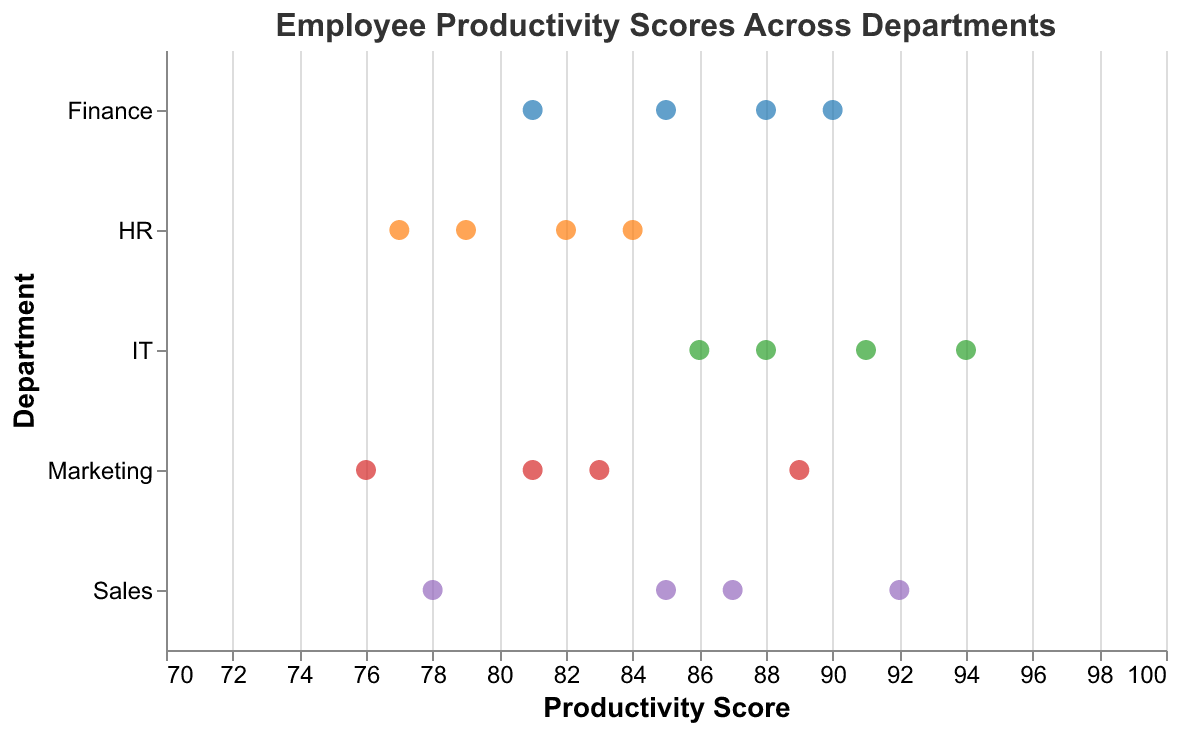What's the title of the plot? The title of the plot is typically placed at the top of the figure and is clearly visible. In this case, the title is "Employee Productivity Scores Across Departments".
Answer: Employee Productivity Scores Across Departments How many employees are in the HR department? The plot shows individual data points for each employee, and by counting these points within the HR department area, we find that there are four employees.
Answer: 4 Which department has the highest individual productivity score? By looking for the highest positioned data point on the x-axis, which represents the productivity score, the highest score is 94 in the IT department.
Answer: IT What's the average productivity score for the Sales department? The productivity scores for Sales are 87, 92, 78, and 85. Summing these up gives 342, and dividing by the number of employees (which is 4) gives an average of 85.5.
Answer: 85.5 Which department has the lowest average productivity score? Calculate the average productivity score for each department: Sales (85.5), Marketing (82.3), IT (89.75), HR (80.5), Finance (86). Comparing these, Marketing has the lowest average productivity score.
Answer: Marketing How many departments have an employee with a productivity score above 90? Identify the departments that have at least one data point above the score of 90: Sales, IT, and Finance have such scores. A total of three departments meet this criterion.
Answer: 3 Is there any department where all employees have productivity scores below 80? Check each department: none of the departments (Sales, Marketing, IT, HR, and Finance) have all employees with scores below 80.
Answer: No What is the range of productivity scores in the Finance department? The productivity scores for Finance are 90, 85, 88, and 81. The range is calculated as the difference between the highest (90) and the lowest (81) scores, which is 90 - 81 = 9.
Answer: 9 Which two departments show the most overlap in their productivity scores? By examining the spread and distribution of scores in all departments, it is clear that the HR and Marketing departments have overlapping scores in the range between 76 and 84.
Answer: HR and Marketing 